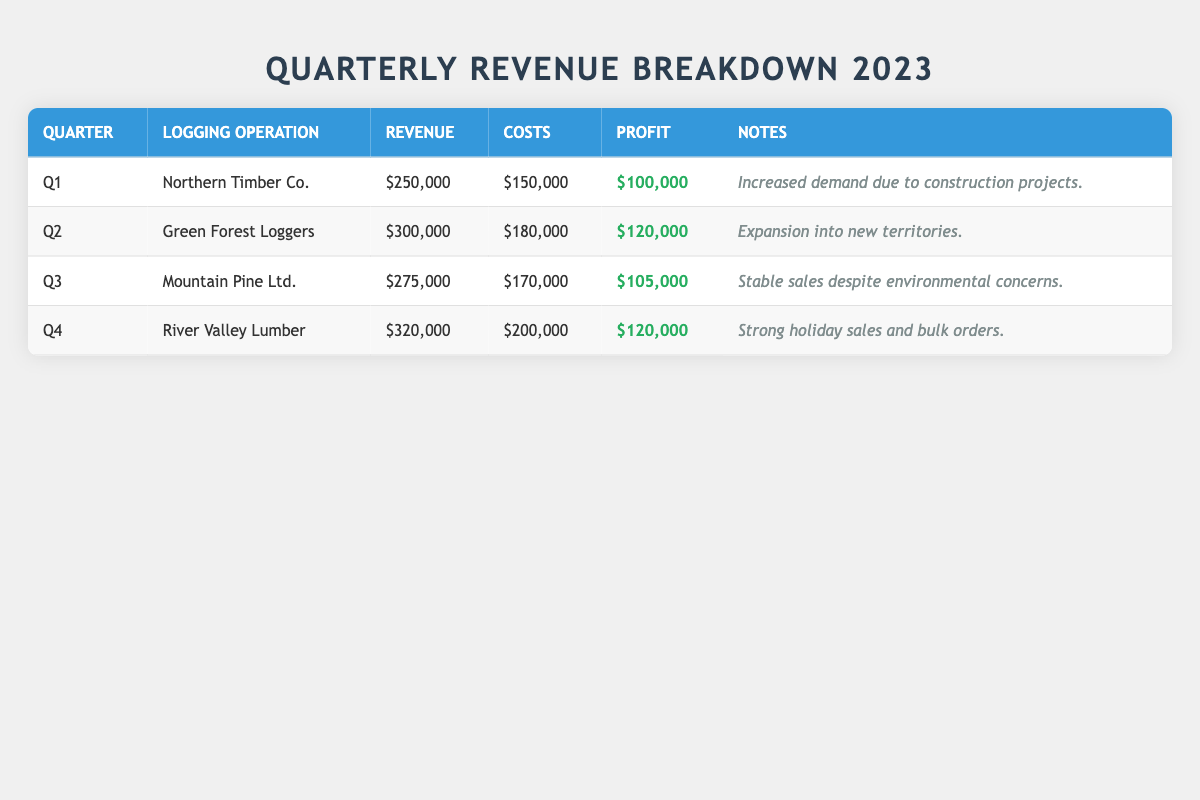What was the profit for Northern Timber Co. in Q1? The profit for Northern Timber Co. is listed in the table as $100,000 for Q1.
Answer: $100,000 Which logging operation had the highest revenue in Q4? The table shows that River Valley Lumber had the highest revenue in Q4, with $320,000.
Answer: River Valley Lumber What is the total revenue generated by Green Forest Loggers and Mountain Pine Ltd. combined? The revenue for Green Forest Loggers (Q2) is $300,000 and for Mountain Pine Ltd. (Q3) is $275,000. Combined, it is $300,000 + $275,000 = $575,000.
Answer: $575,000 Did any logging operation report a profit greater than $120,000 in 2023? Analyzing the profits listed in the table, the highest profit is $120,000, which was achieved by Green Forest Loggers in Q2 and River Valley Lumber in Q4. Thus, no operation reported a profit greater than $120,000.
Answer: No What was the overall profit margin for Mountain Pine Ltd. in Q3? To find the profit margin, divide the profit ($105,000) by the revenue ($275,000) and multiply by 100: ($105,000 / $275,000) * 100 = 38.18%. Therefore, the profit margin is approximately 38.18%.
Answer: 38.18% Which quarter had the lowest costs among all logging operations listed? Reviewing the costs for each quarter: Q1 has $150,000, Q2 has $180,000, Q3 has $170,000, and Q4 has $200,000. The lowest costs are in Q1 at $150,000.
Answer: Q1 What is the average revenue of all logging operations for the year 2023? Adding all revenues: $250,000 (Q1) + $300,000 (Q2) + $275,000 (Q3) + $320,000 (Q4) = $1,145,000; dividing by the number of operations (4) gives an average of $1,145,000 / 4 = $286,250.
Answer: $286,250 Which quarter recorded the highest profit? The profits listed are $100,000 for Q1, $120,000 for Q2, $105,000 for Q3, and $120,000 for Q4. Both Q2 and Q4 recorded the highest profit of $120,000.
Answer: Q2 and Q4 If the total costs for 2023 were $700,000, what was the overall profit for the logging operations? To find the overall profit, first sum up the profits: $100,000 (Q1) + $120,000 (Q2) + $105,000 (Q3) + $120,000 (Q4) = $445,000. Since total costs are $700,000, the overall profit would be $1,145,000 (total revenue) - $700,000 (total costs) = $445,000.
Answer: $445,000 Did any logging operation have a profit of exactly $120,000? From the table, both Green Forest Loggers and River Valley Lumber had profits exactly equal to $120,000 in Q2 and Q4, respectively.
Answer: Yes What percentage of the total revenue was generated by Northern Timber Co. in Q1? Northern Timber Co. generated $250,000 in revenue. The total revenue calculated is $1,145,000. To find the percentage: ($250,000 / $1,145,000) * 100 = approximately 21.83%.
Answer: 21.83% 